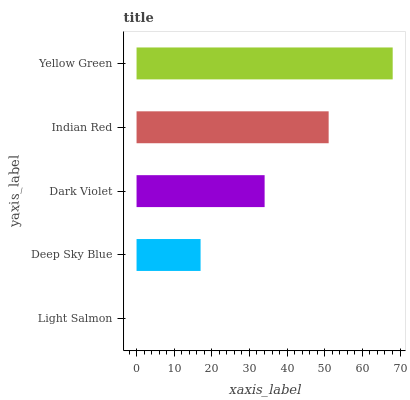Is Light Salmon the minimum?
Answer yes or no. Yes. Is Yellow Green the maximum?
Answer yes or no. Yes. Is Deep Sky Blue the minimum?
Answer yes or no. No. Is Deep Sky Blue the maximum?
Answer yes or no. No. Is Deep Sky Blue greater than Light Salmon?
Answer yes or no. Yes. Is Light Salmon less than Deep Sky Blue?
Answer yes or no. Yes. Is Light Salmon greater than Deep Sky Blue?
Answer yes or no. No. Is Deep Sky Blue less than Light Salmon?
Answer yes or no. No. Is Dark Violet the high median?
Answer yes or no. Yes. Is Dark Violet the low median?
Answer yes or no. Yes. Is Indian Red the high median?
Answer yes or no. No. Is Deep Sky Blue the low median?
Answer yes or no. No. 